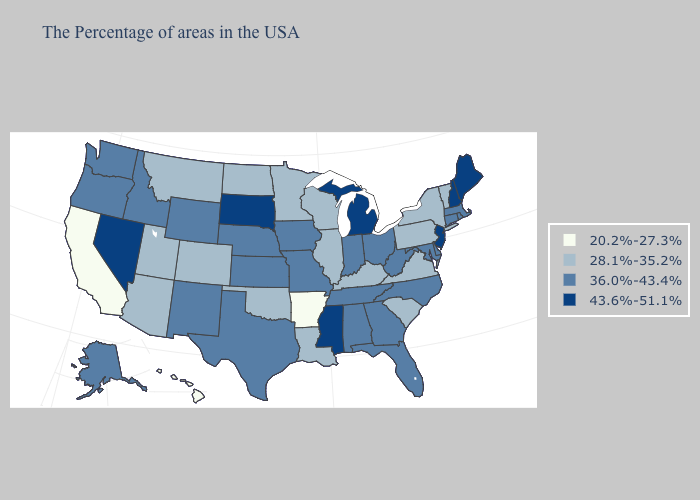Name the states that have a value in the range 36.0%-43.4%?
Write a very short answer. Massachusetts, Rhode Island, Connecticut, Delaware, Maryland, North Carolina, West Virginia, Ohio, Florida, Georgia, Indiana, Alabama, Tennessee, Missouri, Iowa, Kansas, Nebraska, Texas, Wyoming, New Mexico, Idaho, Washington, Oregon, Alaska. Name the states that have a value in the range 43.6%-51.1%?
Concise answer only. Maine, New Hampshire, New Jersey, Michigan, Mississippi, South Dakota, Nevada. Among the states that border Iowa , which have the lowest value?
Short answer required. Wisconsin, Illinois, Minnesota. Does Kansas have the same value as Vermont?
Keep it brief. No. What is the lowest value in the West?
Keep it brief. 20.2%-27.3%. Does the map have missing data?
Keep it brief. No. What is the lowest value in the USA?
Short answer required. 20.2%-27.3%. Which states hav the highest value in the MidWest?
Short answer required. Michigan, South Dakota. Does Arkansas have the lowest value in the USA?
Keep it brief. Yes. What is the value of Virginia?
Keep it brief. 28.1%-35.2%. Among the states that border Oklahoma , does Kansas have the lowest value?
Give a very brief answer. No. Does Tennessee have a lower value than Massachusetts?
Write a very short answer. No. What is the value of Idaho?
Keep it brief. 36.0%-43.4%. Which states hav the highest value in the Northeast?
Concise answer only. Maine, New Hampshire, New Jersey. What is the lowest value in the USA?
Be succinct. 20.2%-27.3%. 